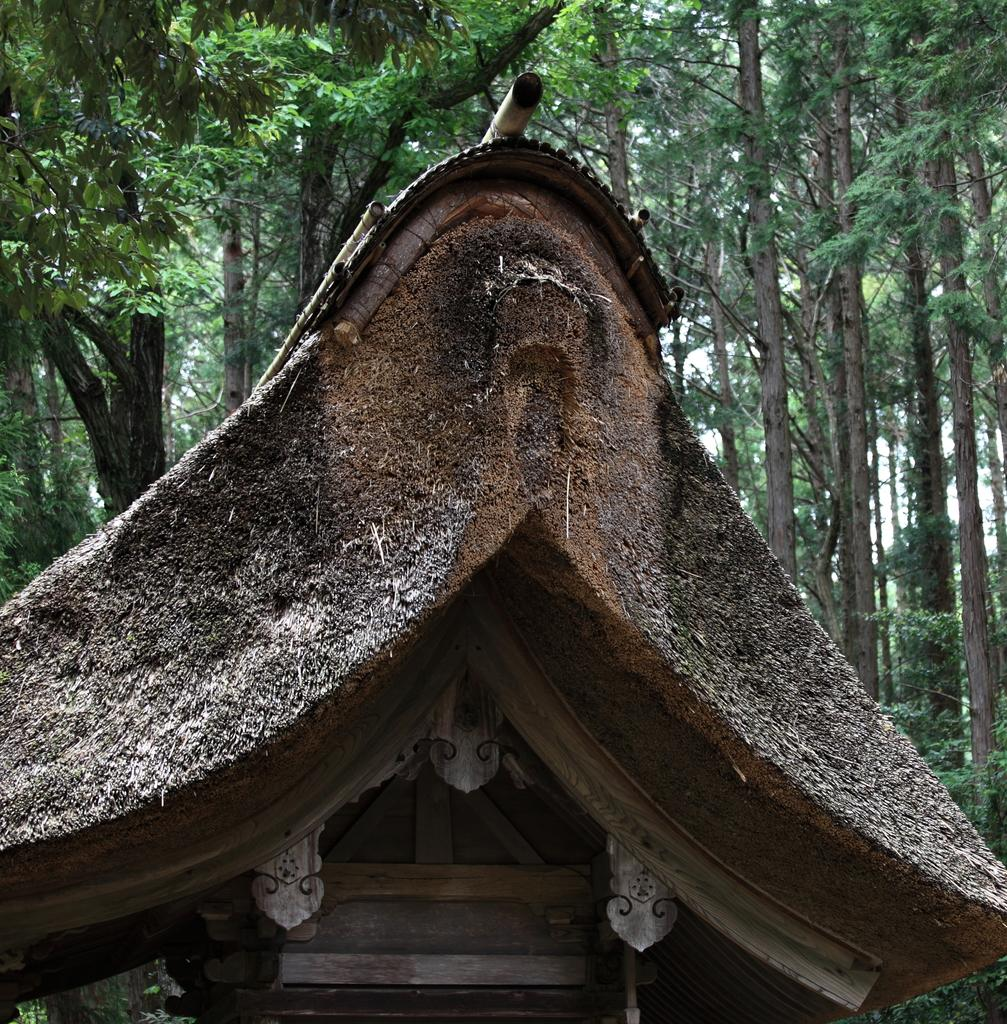What type of structure is present in the image? There is a place with a roof in the image. What type of vegetation can be seen in the image? There are plants and trees visible in the image. What type of card is being used to decorate the plants in the image? There is no card present in the image, and therefore no such decoration can be observed. Can you see a toothbrush or crayon being used in the image? No, there is no toothbrush or crayon present in the image. 